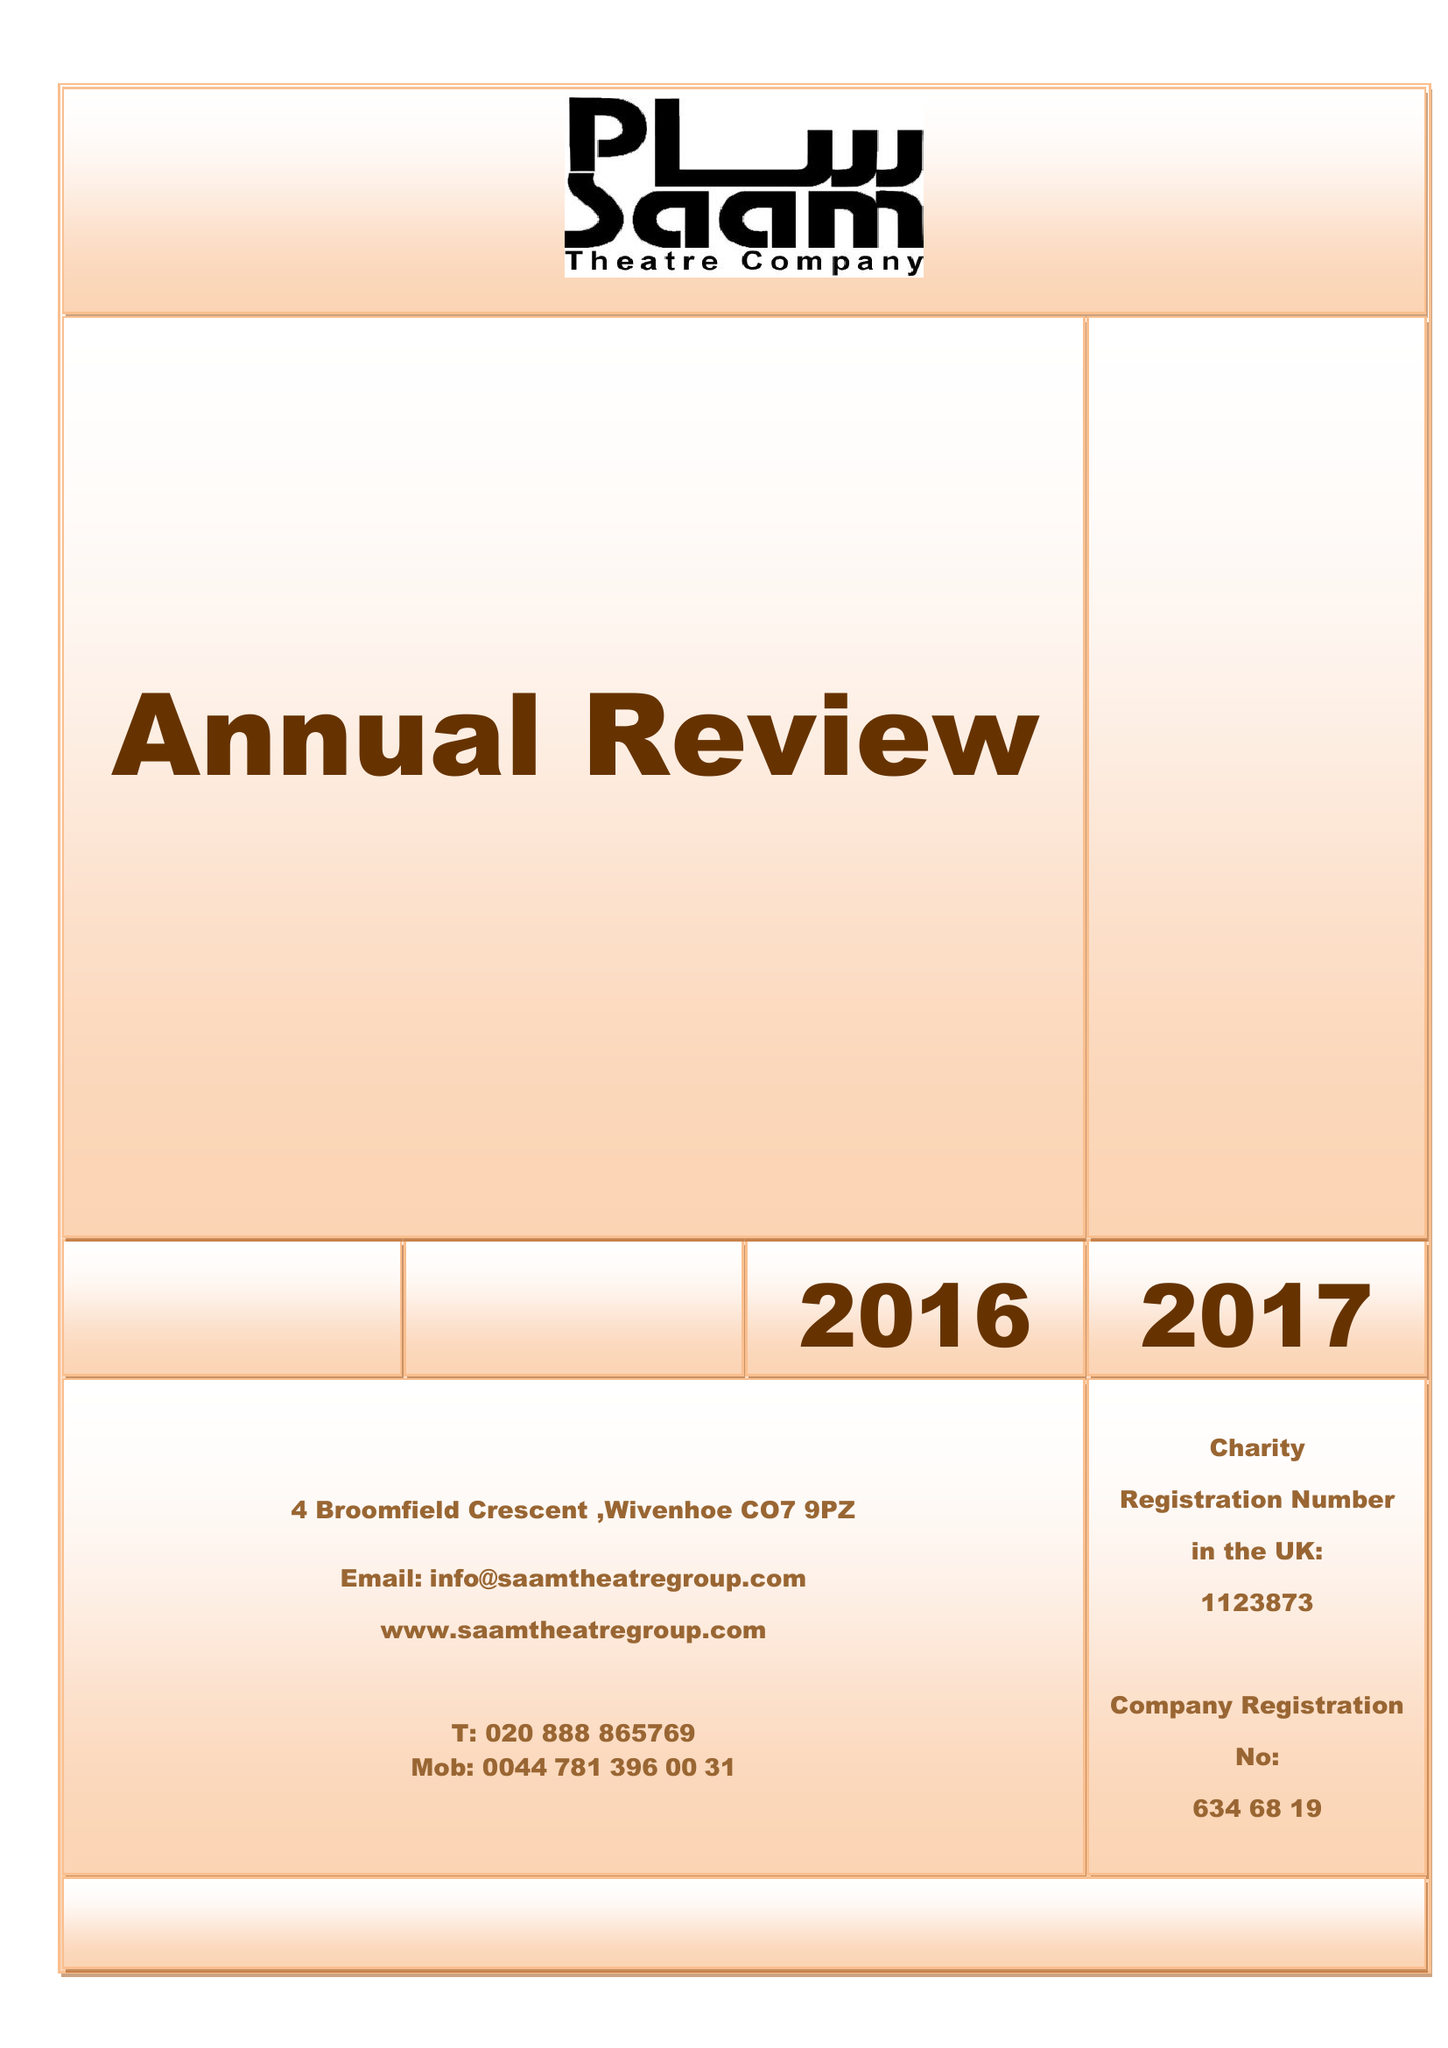What is the value for the report_date?
Answer the question using a single word or phrase. 2017-03-31 